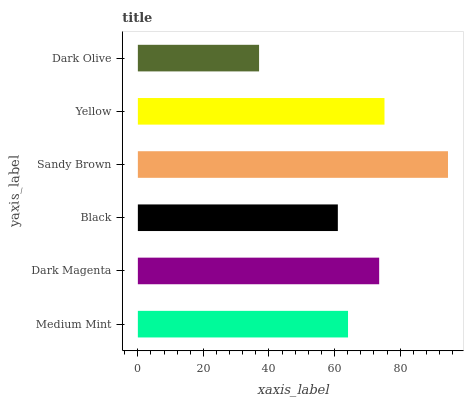Is Dark Olive the minimum?
Answer yes or no. Yes. Is Sandy Brown the maximum?
Answer yes or no. Yes. Is Dark Magenta the minimum?
Answer yes or no. No. Is Dark Magenta the maximum?
Answer yes or no. No. Is Dark Magenta greater than Medium Mint?
Answer yes or no. Yes. Is Medium Mint less than Dark Magenta?
Answer yes or no. Yes. Is Medium Mint greater than Dark Magenta?
Answer yes or no. No. Is Dark Magenta less than Medium Mint?
Answer yes or no. No. Is Dark Magenta the high median?
Answer yes or no. Yes. Is Medium Mint the low median?
Answer yes or no. Yes. Is Medium Mint the high median?
Answer yes or no. No. Is Dark Magenta the low median?
Answer yes or no. No. 